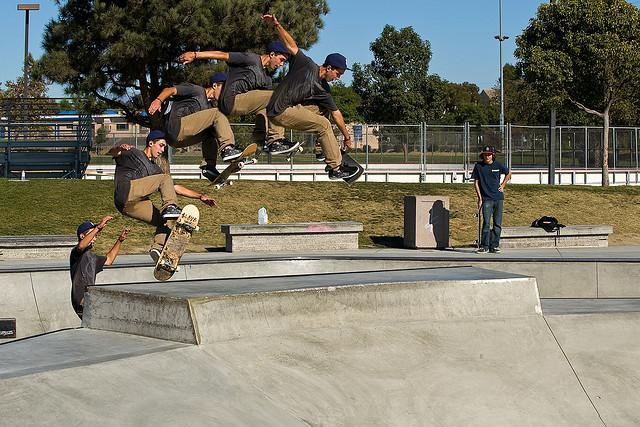How many people wearing tan pants and black shirts are seen here? Please explain your reasoning. one. It is the same person, but it is a photo of them throughout the movements. 